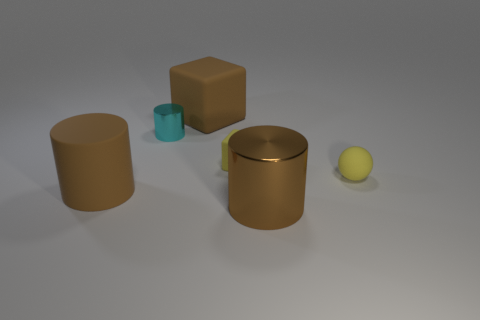Add 2 tiny yellow cubes. How many objects exist? 8 Subtract all blocks. How many objects are left? 4 Add 5 brown matte objects. How many brown matte objects are left? 7 Add 1 brown cylinders. How many brown cylinders exist? 3 Subtract 0 blue cubes. How many objects are left? 6 Subtract all big gray cubes. Subtract all cyan shiny objects. How many objects are left? 5 